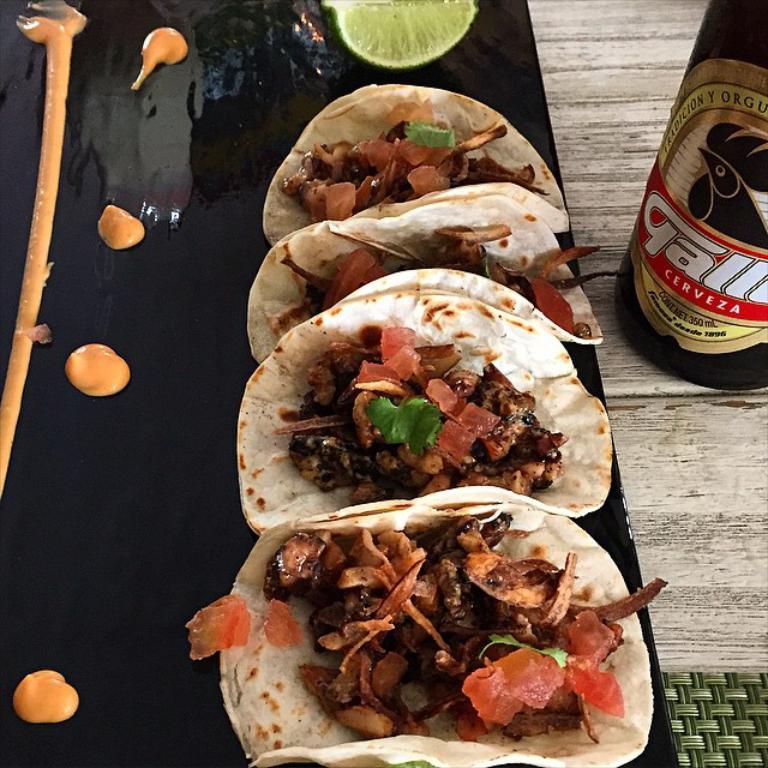How would you summarize this image in a sentence or two? In this picture I can see a food item, a slice of a lemon and cream on the black color plate, there is a wine bottle, that looks like a table mat , on the table. 